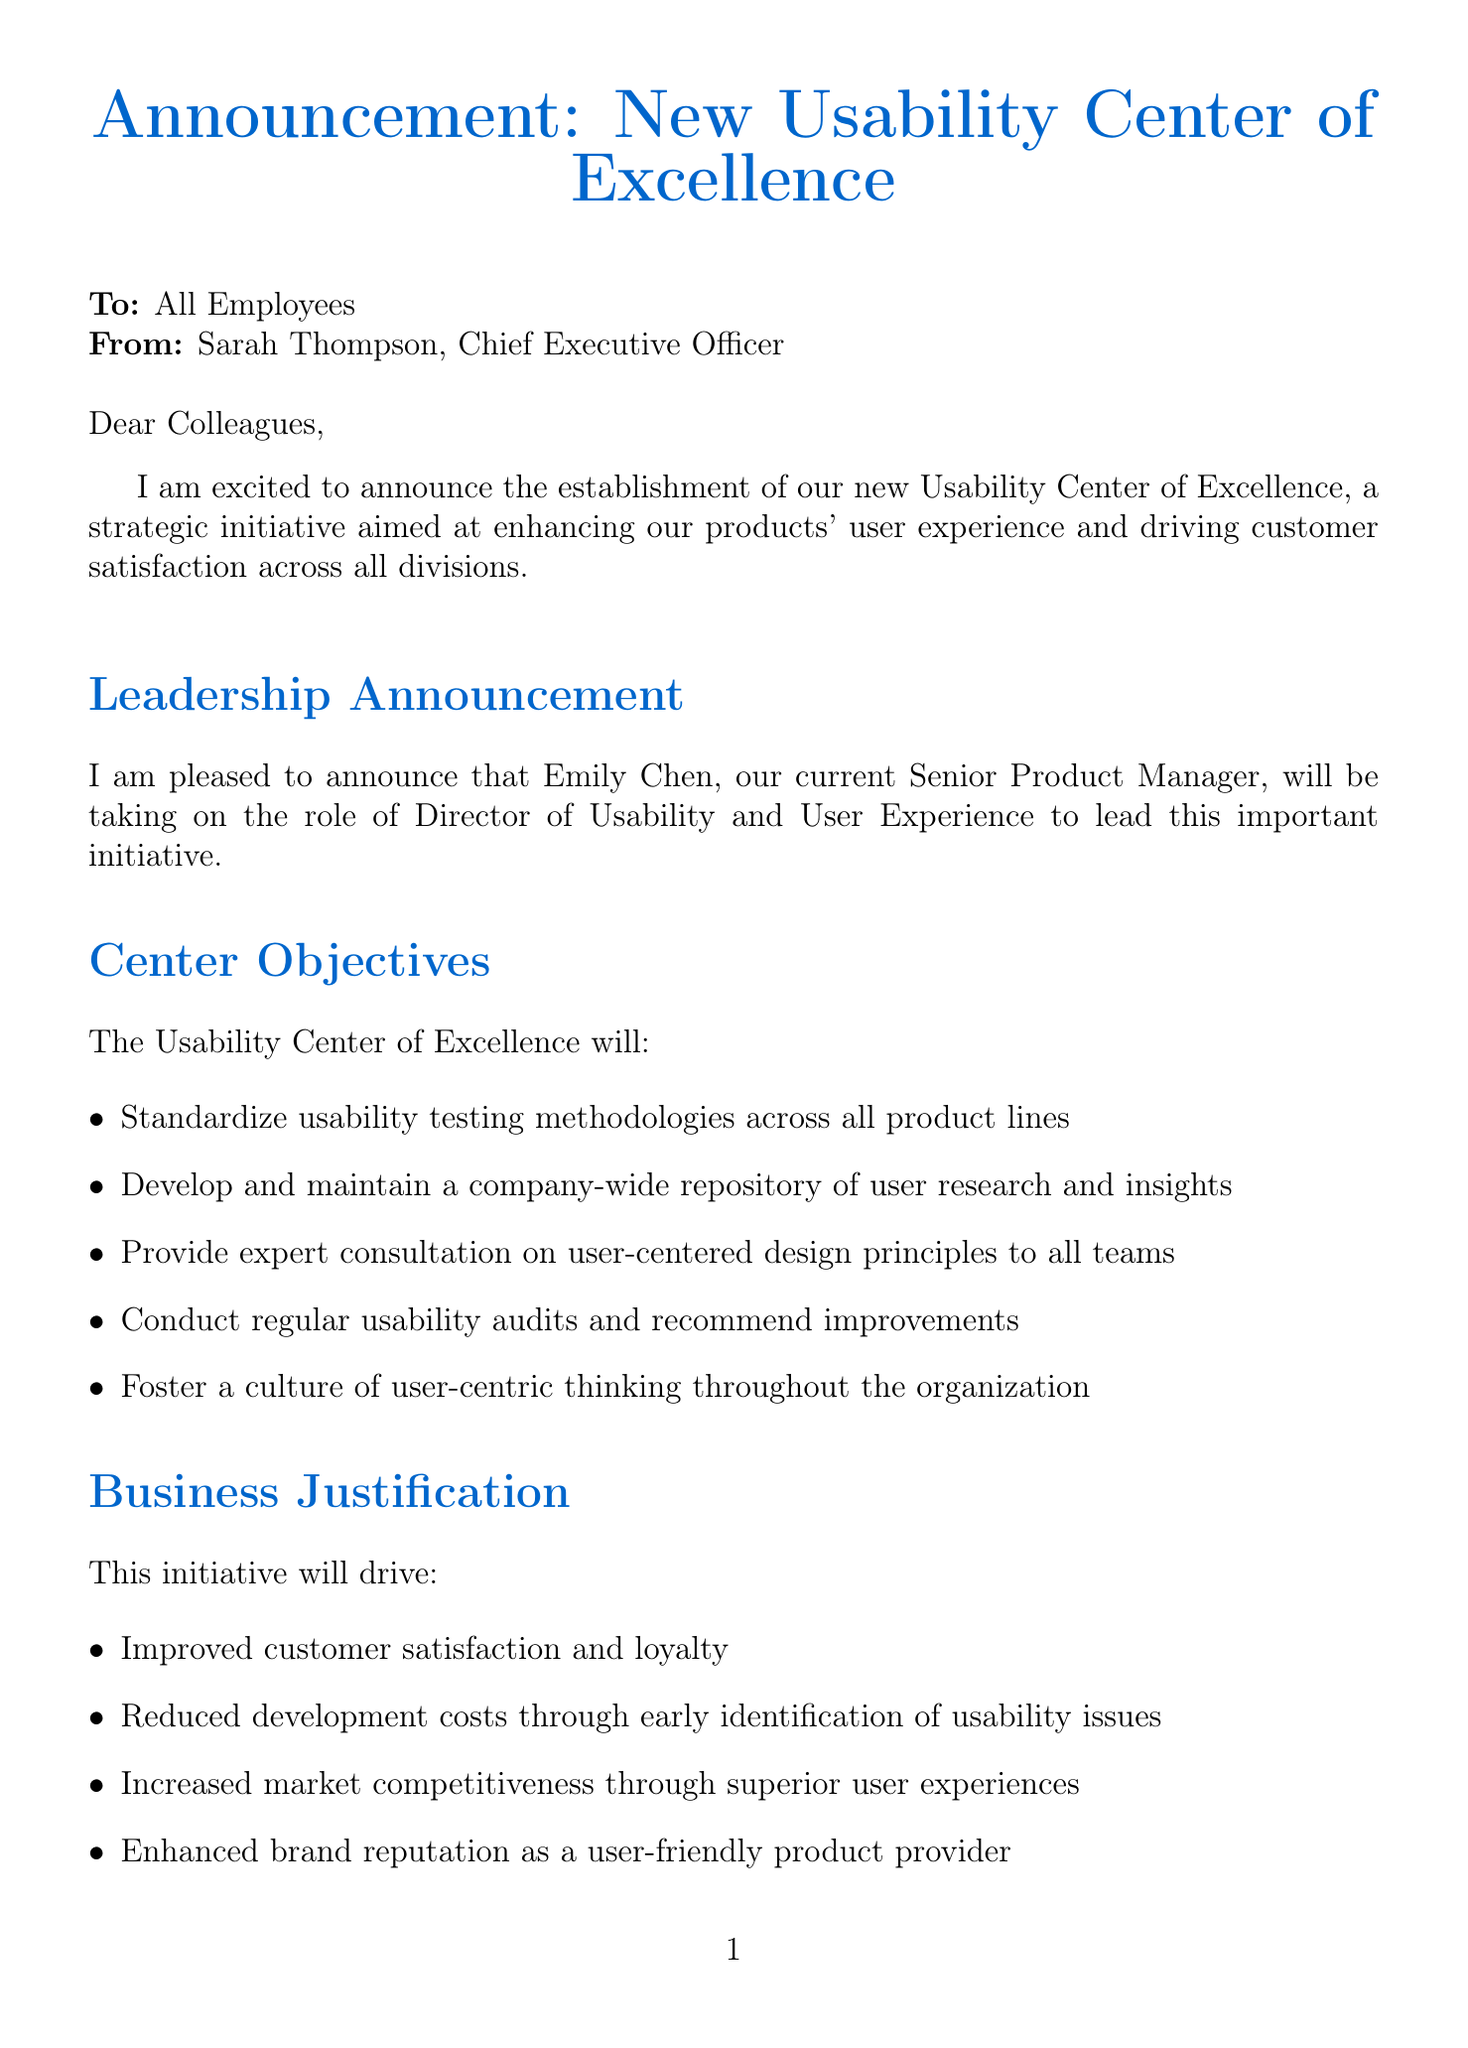What is the title of the announcement? The title of the announcement is stated at the top of the letter.
Answer: Announcement: New Usability Center of Excellence Who is the sender of the memo? The sender's name and title are mentioned in the opening lines of the letter.
Answer: Sarah Thompson What is Emily Chen's new role? The letter specifies Emily's new role in the leadership announcement section.
Answer: Director of Usability and User Experience When is the center scheduled to launch? The implementation timeline section provides the launch date of the center.
Answer: July 1, 2023 What is one objective of the Usability Center of Excellence? The document lists several objectives that the center aims to achieve.
Answer: Standardize usability testing methodologies across all product lines How many UX researchers and designers will be initially hired? The implementation timeline section mentions the initial staffing number.
Answer: 5 What impact will the usability center have on product development? The departmental impact section outlines how different departments will be affected.
Answer: Closer collaboration with UX team from ideation to launch What is the business justification for the Usability Center of Excellence? The letter lists several justifications for establishing the center.
Answer: Improved customer satisfaction and loyalty What call to action does the CEO encourage? The call to action section expresses what employees are encouraged to do regarding the initiative.
Answer: Embrace this initiative and support Emily and her team 